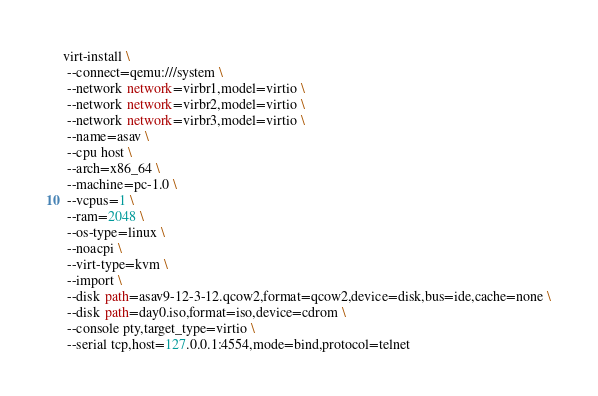<code> <loc_0><loc_0><loc_500><loc_500><_Bash_>virt-install \
 --connect=qemu:///system \
 --network network=virbr1,model=virtio \
 --network network=virbr2,model=virtio \
 --network network=virbr3,model=virtio \
 --name=asav \
 --cpu host \
 --arch=x86_64 \
 --machine=pc-1.0 \
 --vcpus=1 \
 --ram=2048 \
 --os-type=linux \
 --noacpi \
 --virt-type=kvm \
 --import \
 --disk path=asav9-12-3-12.qcow2,format=qcow2,device=disk,bus=ide,cache=none \
 --disk path=day0.iso,format=iso,device=cdrom \
 --console pty,target_type=virtio \
 --serial tcp,host=127.0.0.1:4554,mode=bind,protocol=telnet

</code> 